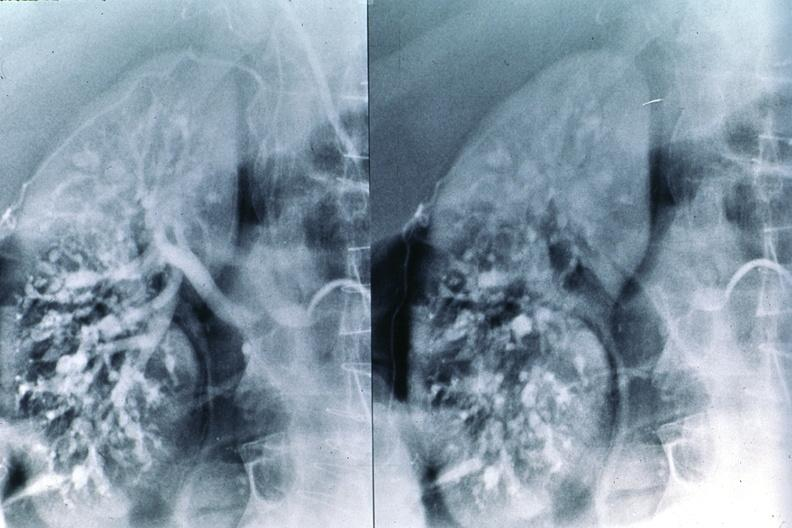does this image show polyarteritis nodosa, kidney arteriogram?
Answer the question using a single word or phrase. Yes 